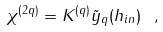Convert formula to latex. <formula><loc_0><loc_0><loc_500><loc_500>\chi ^ { ( 2 q ) } = K ^ { ( q ) } \tilde { y } _ { q } ( { h } _ { i n } ) \ ,</formula> 